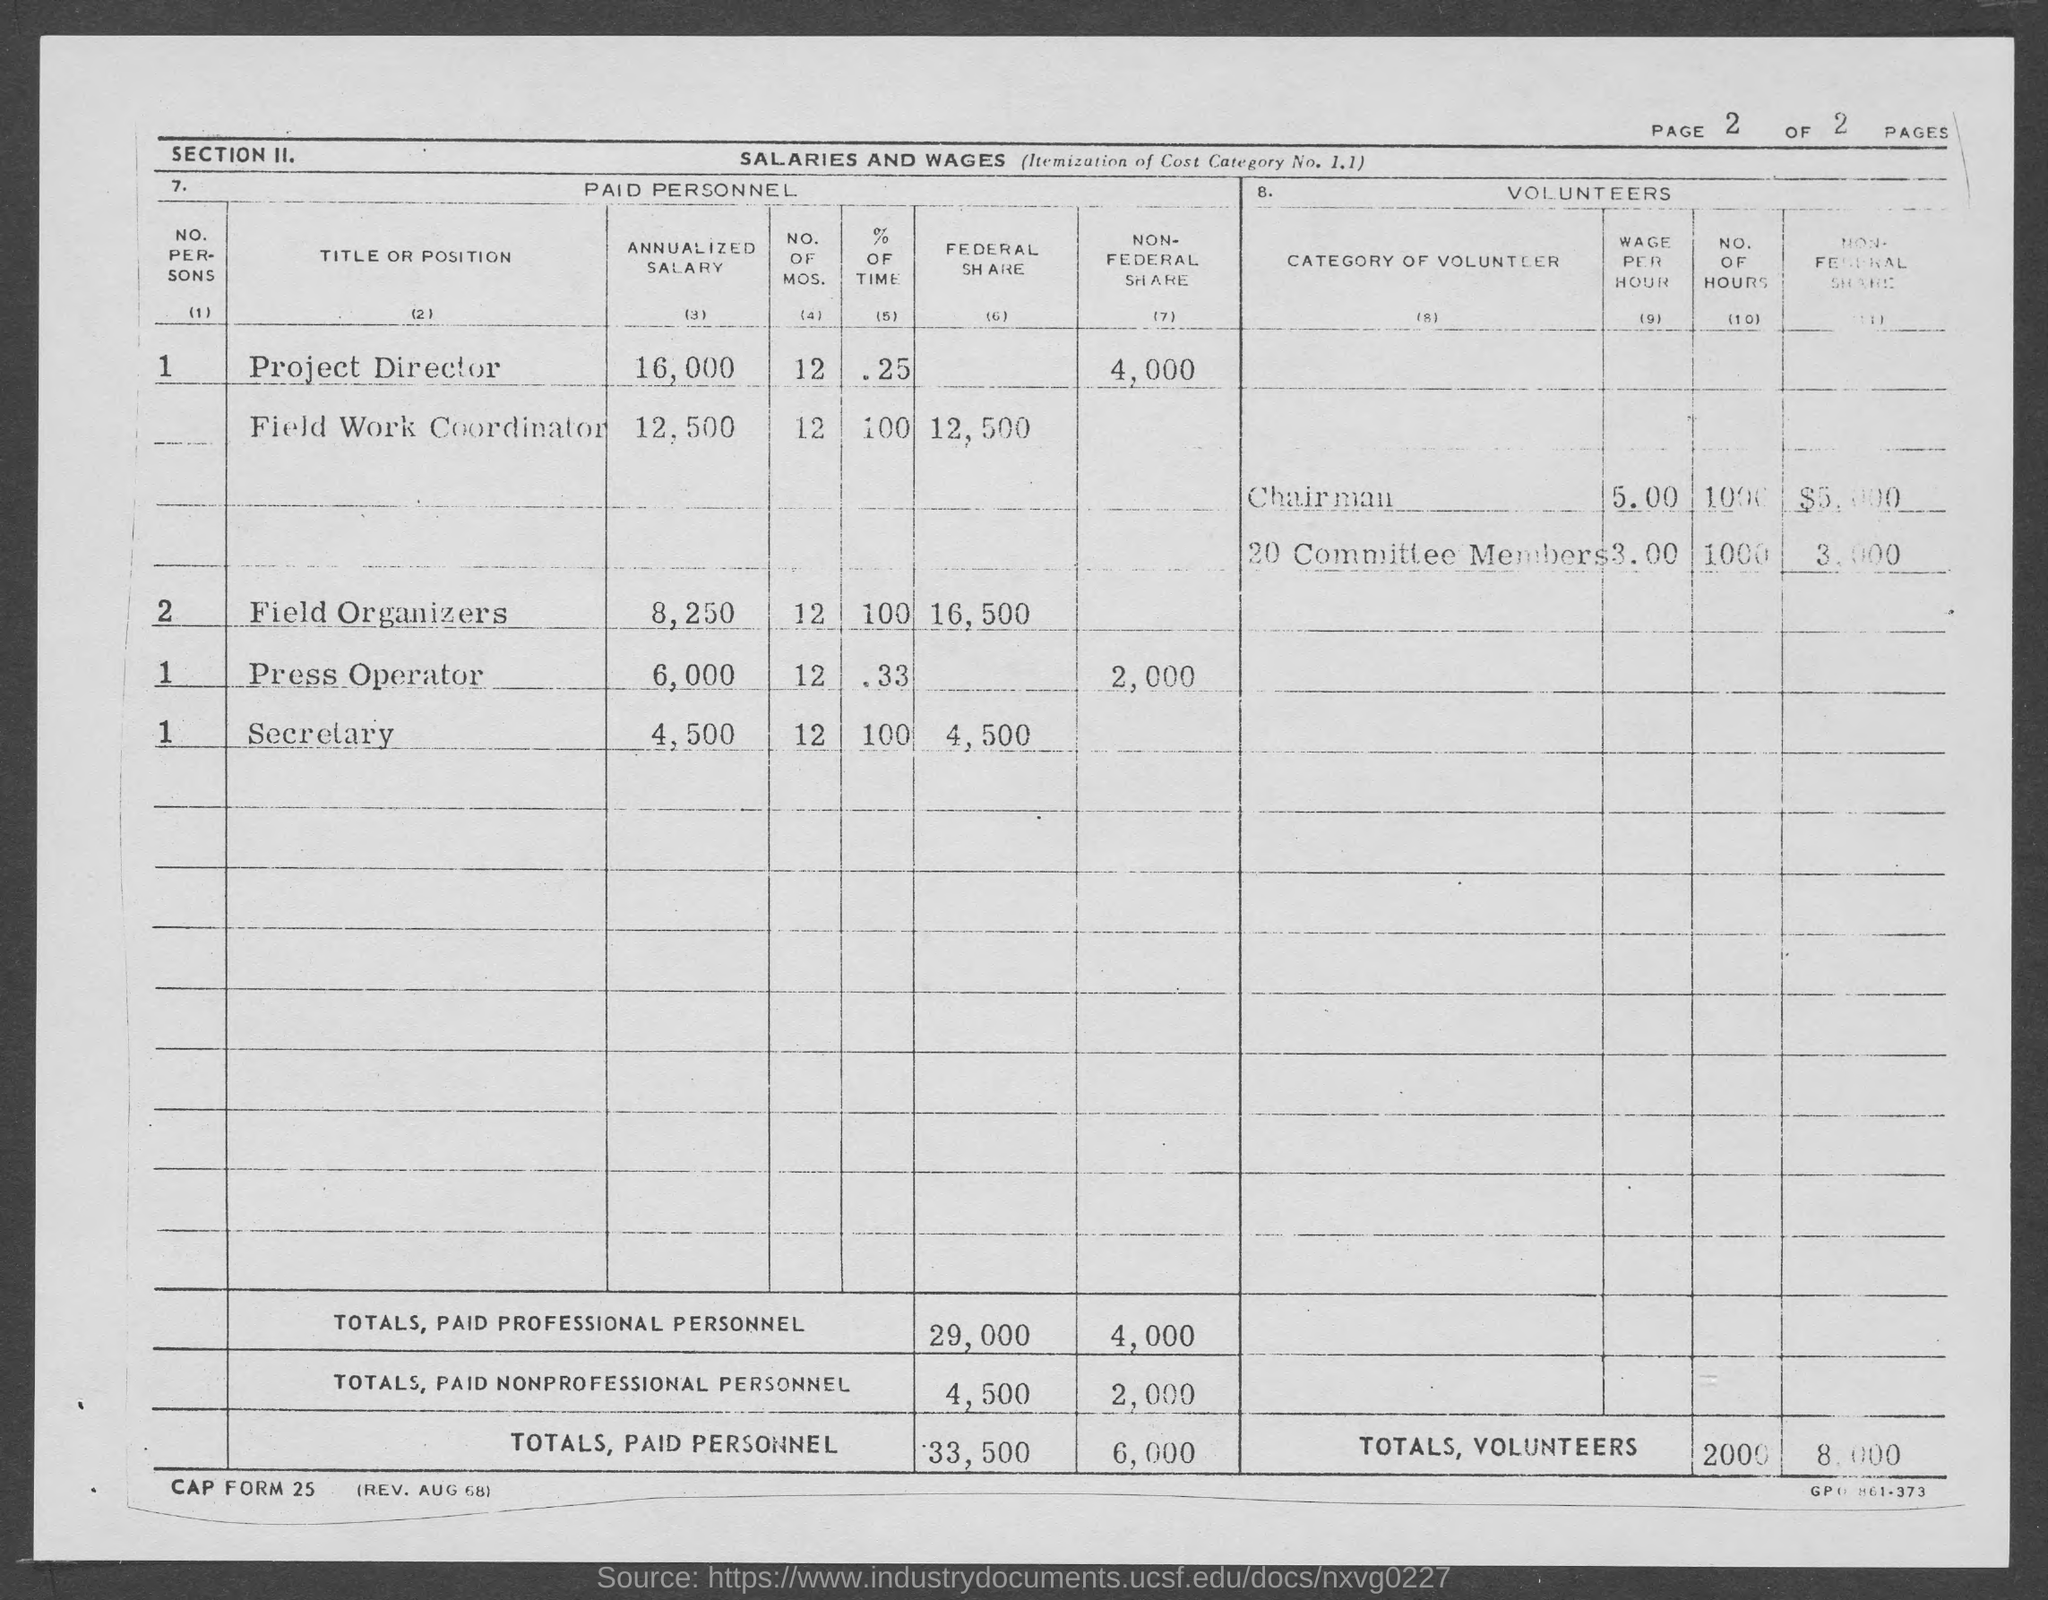Specify some key components in this picture. The annual salary of Field Organizers is approximately $8,250 per year. The total cost of the project is $33,500, with the Federal share being $33,500. The annualized salary of a Press Operator is approximately 6,000. The annualized salary of a Field Work Coordinator is approximately $12,500. The non-federal share in the totals for paid personnel is $6,000. 